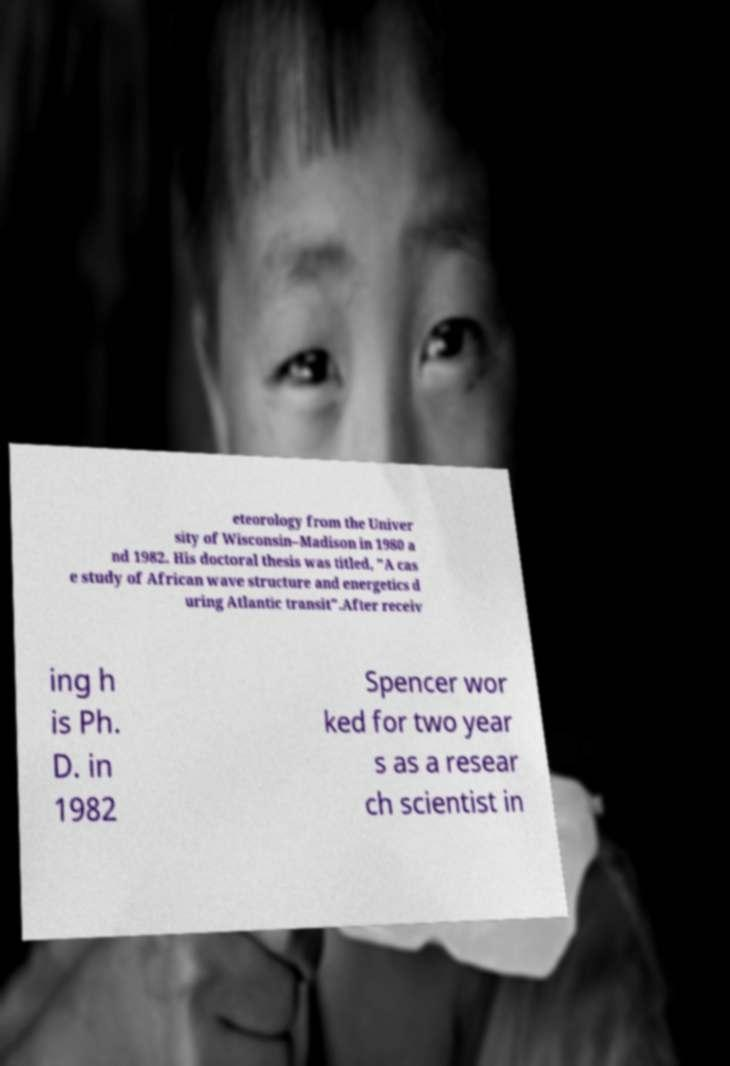There's text embedded in this image that I need extracted. Can you transcribe it verbatim? eteorology from the Univer sity of Wisconsin–Madison in 1980 a nd 1982. His doctoral thesis was titled, "A cas e study of African wave structure and energetics d uring Atlantic transit".After receiv ing h is Ph. D. in 1982 Spencer wor ked for two year s as a resear ch scientist in 